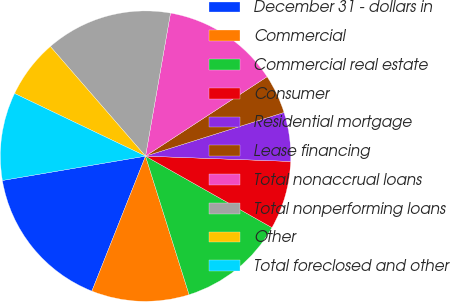Convert chart. <chart><loc_0><loc_0><loc_500><loc_500><pie_chart><fcel>December 31 - dollars in<fcel>Commercial<fcel>Commercial real estate<fcel>Consumer<fcel>Residential mortgage<fcel>Lease financing<fcel>Total nonaccrual loans<fcel>Total nonperforming loans<fcel>Other<fcel>Total foreclosed and other<nl><fcel>16.3%<fcel>10.87%<fcel>11.96%<fcel>7.61%<fcel>5.44%<fcel>4.35%<fcel>13.04%<fcel>14.13%<fcel>6.52%<fcel>9.78%<nl></chart> 